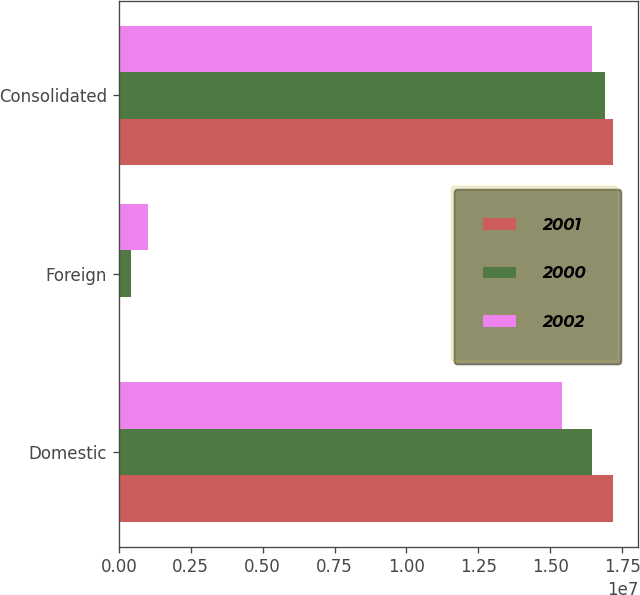Convert chart to OTSL. <chart><loc_0><loc_0><loc_500><loc_500><stacked_bar_chart><ecel><fcel>Domestic<fcel>Foreign<fcel>Consolidated<nl><fcel>2001<fcel>1.71942e+07<fcel>773<fcel>1.7195e+07<nl><fcel>2000<fcel>1.64681e+07<fcel>421870<fcel>1.68899e+07<nl><fcel>2002<fcel>1.54259e+07<fcel>1.01983e+06<fcel>1.64457e+07<nl></chart> 